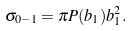Convert formula to latex. <formula><loc_0><loc_0><loc_500><loc_500>\sigma _ { 0 - 1 } = \pi P ( b _ { 1 } ) b _ { 1 } ^ { 2 } .</formula> 